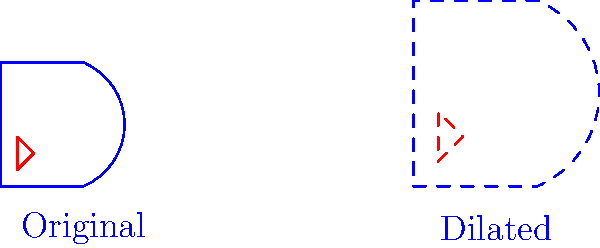In preparation for the upcoming Swedish Speedway Championship, your rival team has decided to update their helmet design. The original design is shown on the left, and a dilated version is on the right. If the scale factor of the dilation is $1.5$, what is the ratio of the area of the dilated red logo to the area of the original red logo? To solve this problem, let's follow these steps:

1) Recall that when a figure is dilated by a scale factor $k$, its linear dimensions (length, width) are multiplied by $k$.

2) The scale factor given in the question is $1.5$.

3) For areas, the effect of dilation is squared. If a figure is dilated by a scale factor $k$, its area is multiplied by $k^2$.

4) In this case, the area scale factor is:
   $$(1.5)^2 = 2.25$$

5) This means the area of the dilated logo is 2.25 times the area of the original logo.

6) The ratio of the dilated logo area to the original logo area is thus 2.25 : 1.

Therefore, the ratio of the area of the dilated red logo to the area of the original red logo is 2.25 : 1.
Answer: 2.25 : 1 